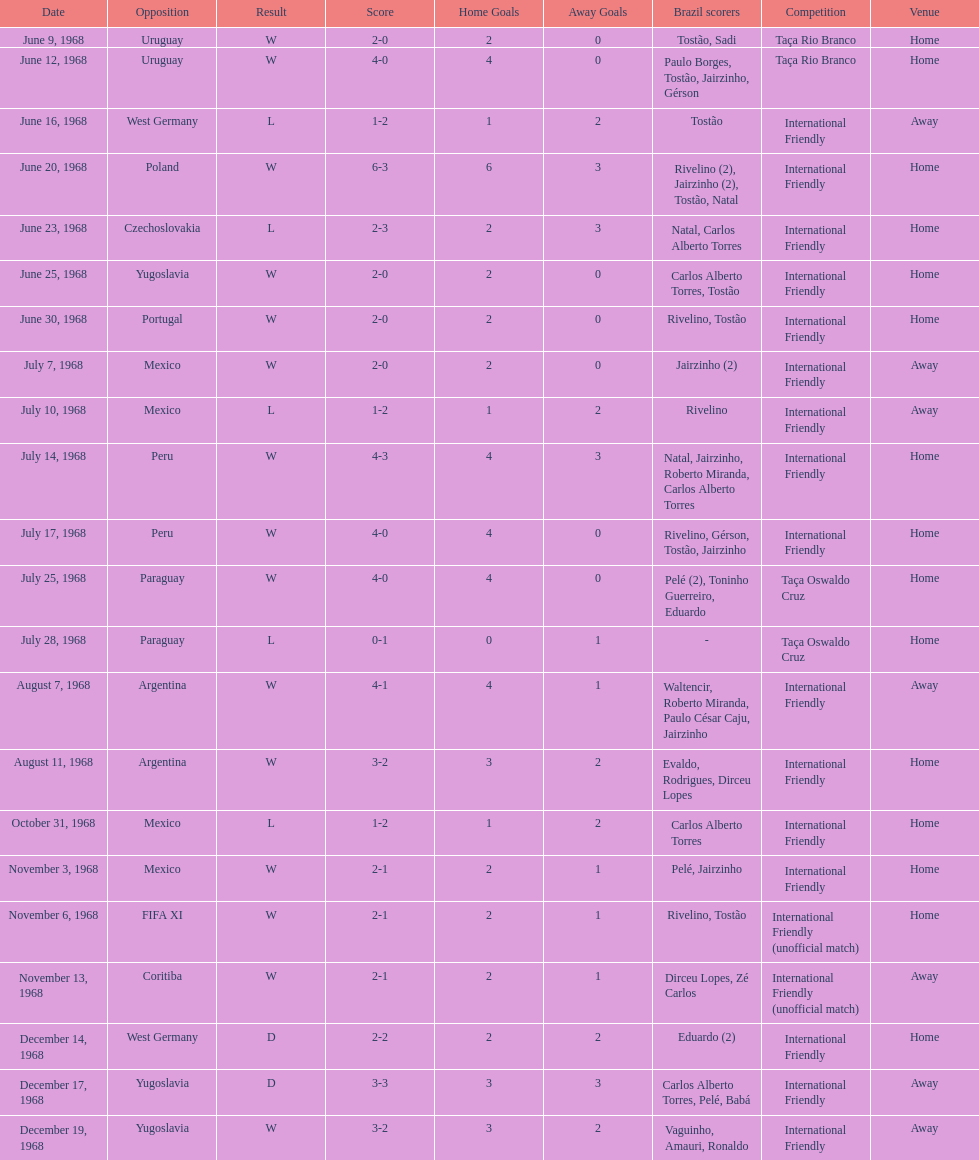Who played brazil previous to the game on june 30th? Yugoslavia. Parse the table in full. {'header': ['Date', 'Opposition', 'Result', 'Score', 'Home Goals', 'Away Goals', 'Brazil scorers', 'Competition', 'Venue'], 'rows': [['June 9, 1968', 'Uruguay', 'W', '2-0', '2', '0', 'Tostão, Sadi', 'Taça Rio Branco', 'Home'], ['June 12, 1968', 'Uruguay', 'W', '4-0', '4', '0', 'Paulo Borges, Tostão, Jairzinho, Gérson', 'Taça Rio Branco', 'Home'], ['June 16, 1968', 'West Germany', 'L', '1-2', '1', '2', 'Tostão', 'International Friendly', 'Away'], ['June 20, 1968', 'Poland', 'W', '6-3', '6', '3', 'Rivelino (2), Jairzinho (2), Tostão, Natal', 'International Friendly', 'Home'], ['June 23, 1968', 'Czechoslovakia', 'L', '2-3', '2', '3', 'Natal, Carlos Alberto Torres', 'International Friendly', 'Home'], ['June 25, 1968', 'Yugoslavia', 'W', '2-0', '2', '0', 'Carlos Alberto Torres, Tostão', 'International Friendly', 'Home'], ['June 30, 1968', 'Portugal', 'W', '2-0', '2', '0', 'Rivelino, Tostão', 'International Friendly', 'Home'], ['July 7, 1968', 'Mexico', 'W', '2-0', '2', '0', 'Jairzinho (2)', 'International Friendly', 'Away'], ['July 10, 1968', 'Mexico', 'L', '1-2', '1', '2', 'Rivelino', 'International Friendly', 'Away'], ['July 14, 1968', 'Peru', 'W', '4-3', '4', '3', 'Natal, Jairzinho, Roberto Miranda, Carlos Alberto Torres', 'International Friendly', 'Home'], ['July 17, 1968', 'Peru', 'W', '4-0', '4', '0', 'Rivelino, Gérson, Tostão, Jairzinho', 'International Friendly', 'Home'], ['July 25, 1968', 'Paraguay', 'W', '4-0', '4', '0', 'Pelé (2), Toninho Guerreiro, Eduardo', 'Taça Oswaldo Cruz', 'Home'], ['July 28, 1968', 'Paraguay', 'L', '0-1', '0', '1', '-', 'Taça Oswaldo Cruz', 'Home'], ['August 7, 1968', 'Argentina', 'W', '4-1', '4', '1', 'Waltencir, Roberto Miranda, Paulo César Caju, Jairzinho', 'International Friendly', 'Away'], ['August 11, 1968', 'Argentina', 'W', '3-2', '3', '2', 'Evaldo, Rodrigues, Dirceu Lopes', 'International Friendly', 'Home'], ['October 31, 1968', 'Mexico', 'L', '1-2', '1', '2', 'Carlos Alberto Torres', 'International Friendly', 'Home'], ['November 3, 1968', 'Mexico', 'W', '2-1', '2', '1', 'Pelé, Jairzinho', 'International Friendly', 'Home'], ['November 6, 1968', 'FIFA XI', 'W', '2-1', '2', '1', 'Rivelino, Tostão', 'International Friendly (unofficial match)', 'Home'], ['November 13, 1968', 'Coritiba', 'W', '2-1', '2', '1', 'Dirceu Lopes, Zé Carlos', 'International Friendly (unofficial match)', 'Away'], ['December 14, 1968', 'West Germany', 'D', '2-2', '2', '2', 'Eduardo (2)', 'International Friendly', 'Home'], ['December 17, 1968', 'Yugoslavia', 'D', '3-3', '3', '3', 'Carlos Alberto Torres, Pelé, Babá', 'International Friendly', 'Away'], ['December 19, 1968', 'Yugoslavia', 'W', '3-2', '3', '2', 'Vaguinho, Amauri, Ronaldo', 'International Friendly', 'Away']]} 